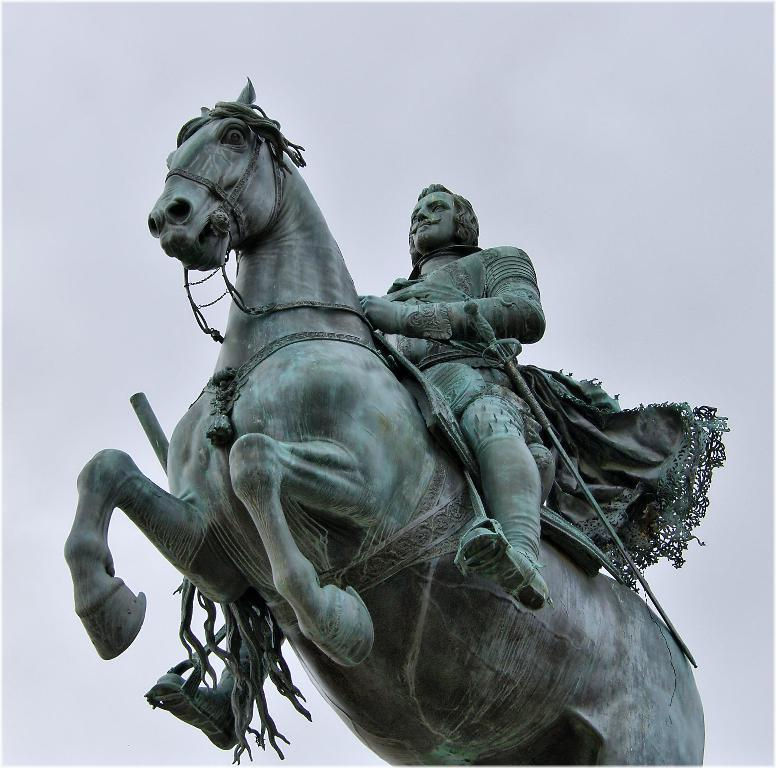What type of statues can be seen in the image? There is a statue of a horse and a statue of a man in the image. Can you describe the subjects of the statues? The statue of a horse depicts a horse, and the statue of a man depicts a man. What type of alarm is attached to the horse's stocking in the image? There is no alarm or stocking present in the image; the statues are not wearing any clothing or accessories. 